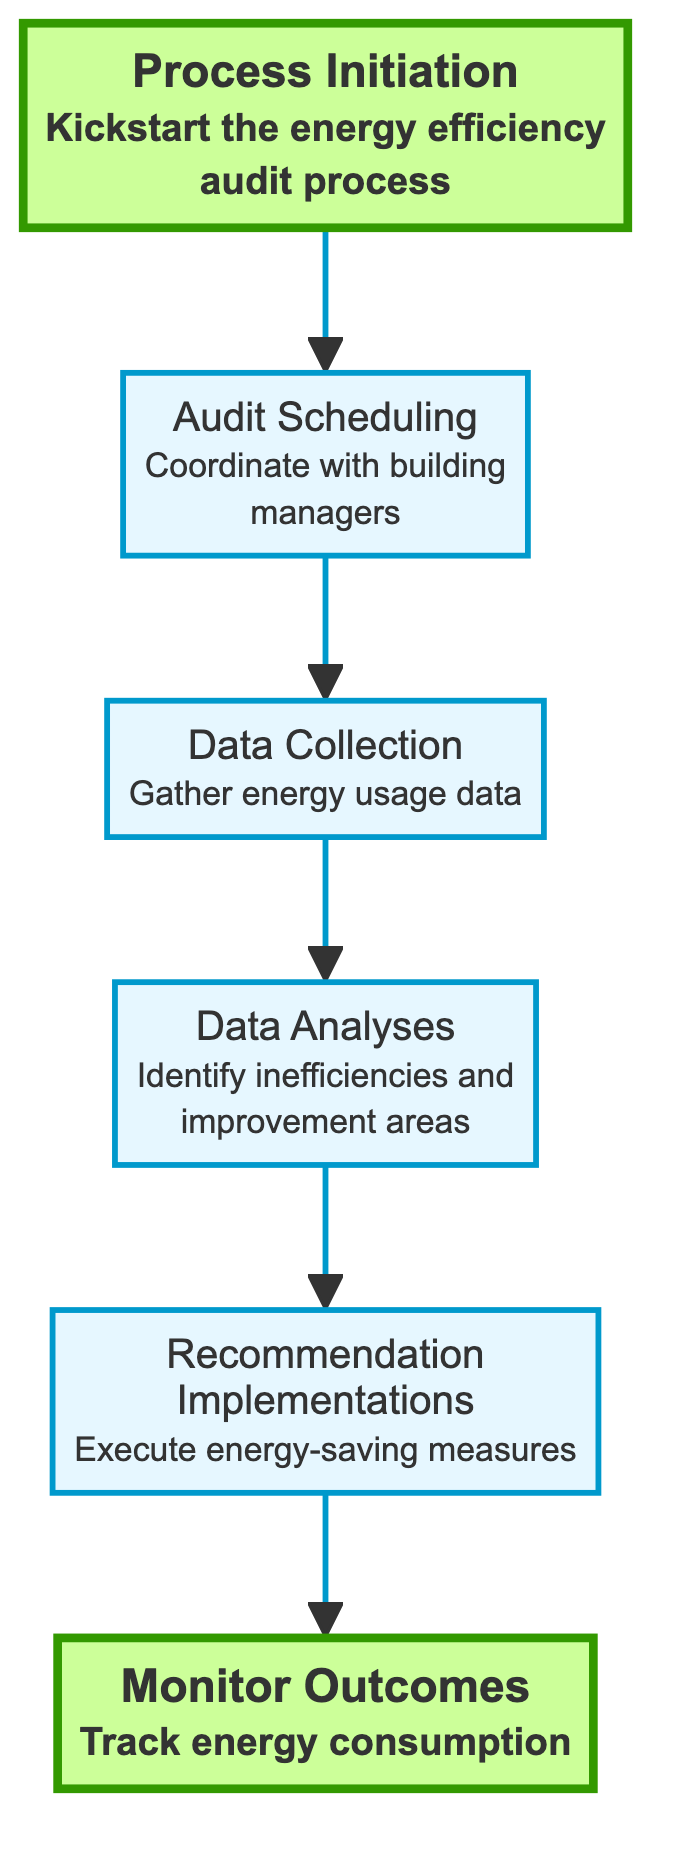What is the first step in the energy efficiency audit process? The diagram indicates that the first step is labeled as "Process Initiation." This step involves gaining approval from municipal leadership, which kickstarts the entire audit process.
Answer: Process Initiation How many nodes are present in the flowchart? By counting the distinct labeled steps in the flowchart, there are six nodes: Process Initiation, Audit Scheduling, Data Collection, Data Analyses, Recommendation Implementations, and Monitor Outcomes.
Answer: 6 What follows the Data Collection step in the flowchart? Looking at the flowchart, after the "Data Collection" step, the next step is "Data Analyses." This indicates that data collected on energy usage is then analyzed for patterns and inefficiencies.
Answer: Data Analyses Which step is connected to Monitoring Outcomes? The diagram shows that the "Monitor Outcomes" step is directly connected to "Recommendation Implementations." This indicates that monitoring occurs after recommendations have been implemented to track energy consumption.
Answer: Recommendation Implementations What is the main purpose of Data Analyses? Within the diagram, the purpose of "Data Analyses" is to identify patterns, inefficiencies, and areas for improvement based on the collected data regarding energy usage.
Answer: Identify patterns, inefficiencies, and areas for improvement What is the relationship between Audit Scheduling and Process Initiation? The flow from "Process Initiation" to "Audit Scheduling" indicates that once the audit process is initiated, the next task is to schedule the audit by coordinating with building managers. This establishes a sequential flow from one step to another.
Answer: Audit Scheduling follows Process Initiation How does the flowchart illustrate the relationship between Recommendation Implementations and Data Analyses? In the flowchart, "Recommendation Implementations" follows "Data Analyses," indicating that the recommendations for energy-saving measures are executed only after data from the audit has been analyzed to identify inefficiencies and improvement areas.
Answer: Recommendation Implementations follow Data Analyses Which process requires approval from municipal leadership? The diagram clearly states that "Process Initiation" requires approval from municipal leadership to kickstart the energy efficiency audit process.
Answer: Process Initiation Identify the ultimate goal of the audit process as illustrated in the diagram. The final step labeled "Monitor Outcomes" is essential to the overall goal of the audit process as it involves tracking energy consumption to ensure that the efficiency improvements are sustained over time.
Answer: Monitor Outcomes 